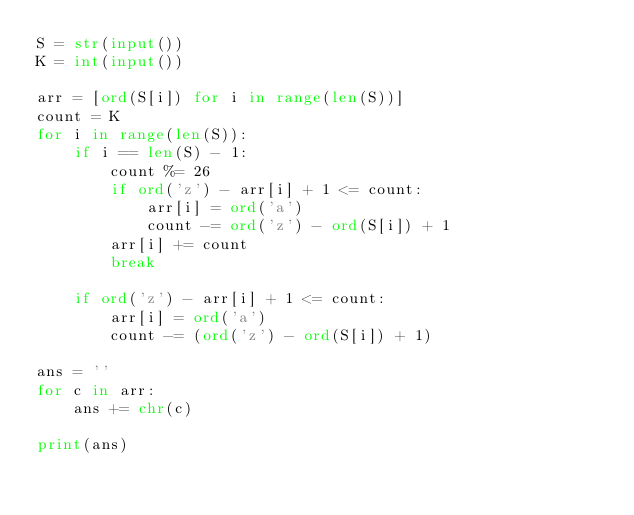<code> <loc_0><loc_0><loc_500><loc_500><_Python_>S = str(input())
K = int(input())

arr = [ord(S[i]) for i in range(len(S))]
count = K
for i in range(len(S)):
    if i == len(S) - 1:
        count %= 26
        if ord('z') - arr[i] + 1 <= count:
            arr[i] = ord('a')
            count -= ord('z') - ord(S[i]) + 1
        arr[i] += count
        break

    if ord('z') - arr[i] + 1 <= count:
        arr[i] = ord('a')
        count -= (ord('z') - ord(S[i]) + 1)

ans = ''
for c in arr:
    ans += chr(c)

print(ans)
</code> 